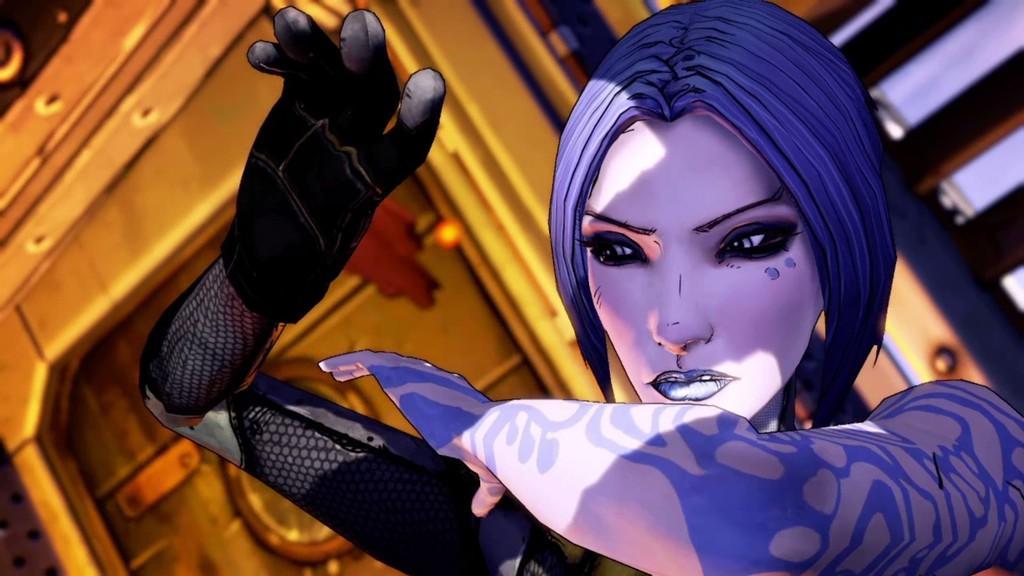Describe this image in one or two sentences. This is an animated image in which we see a person. 